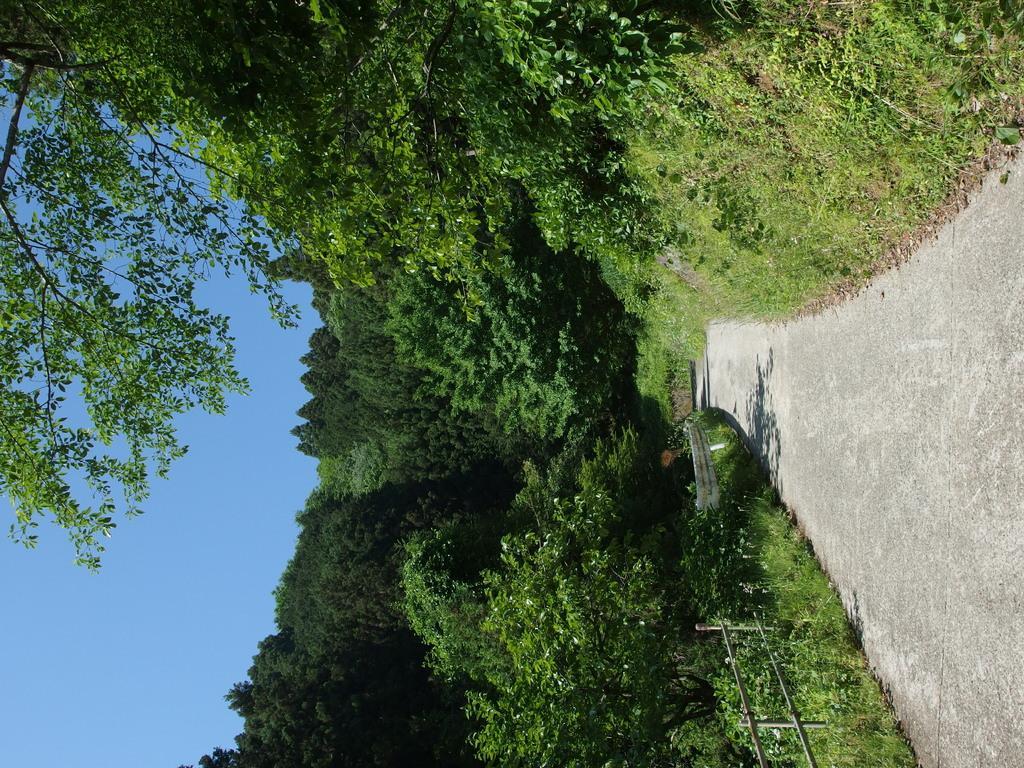Could you give a brief overview of what you see in this image? In the picture I can see can see plants, trees, fence and the grass. In the background I can see the sky. 